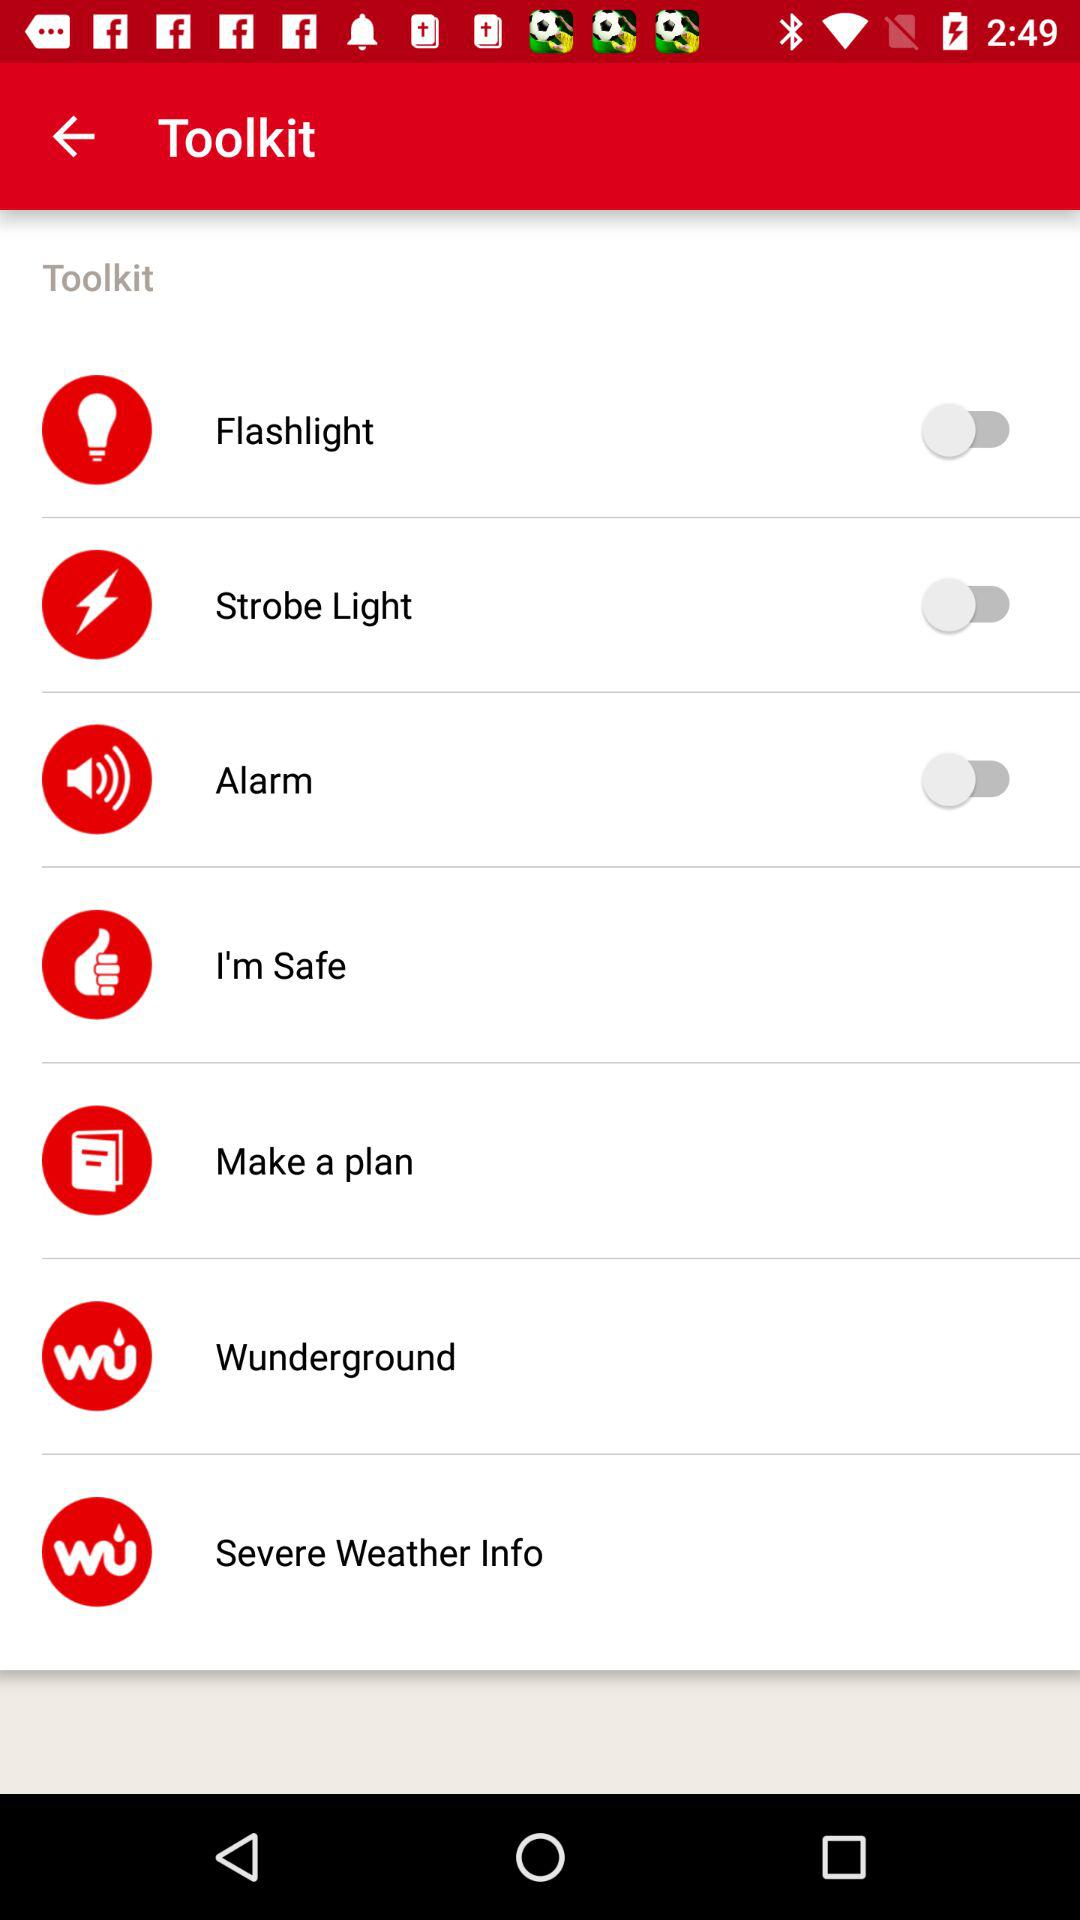What is the status of "Make a plan"?
When the provided information is insufficient, respond with <no answer>. <no answer> 